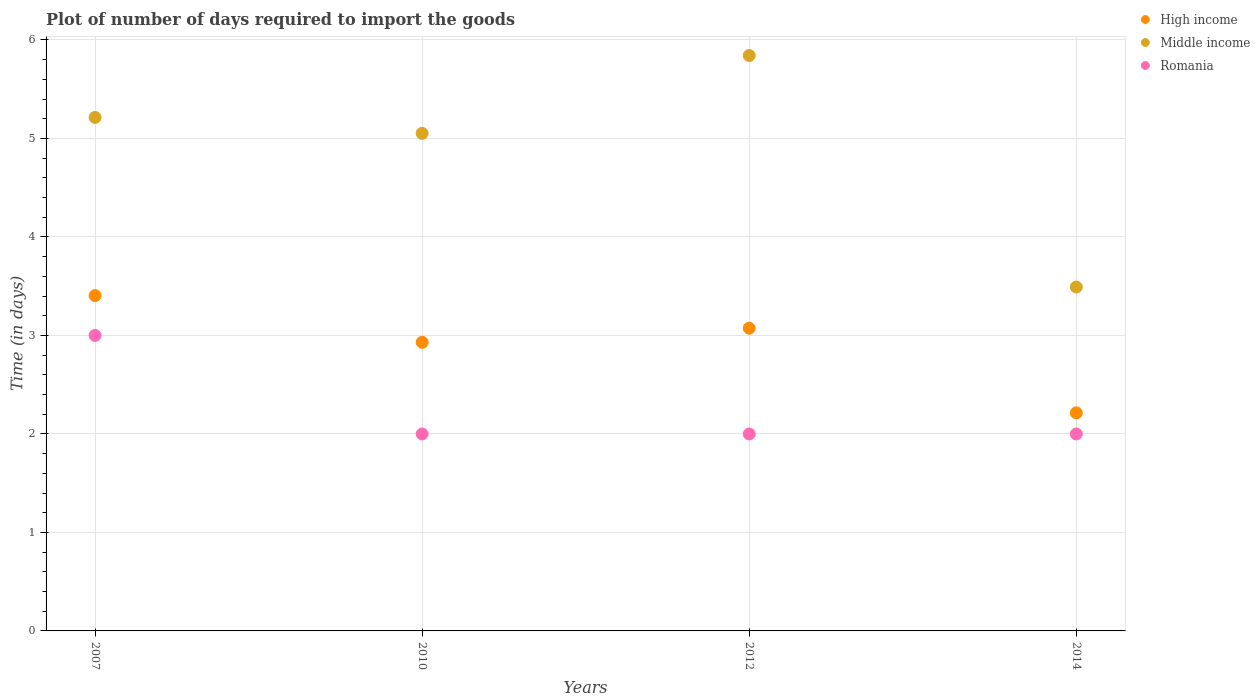How many different coloured dotlines are there?
Make the answer very short. 3. Is the number of dotlines equal to the number of legend labels?
Offer a terse response. Yes. What is the time required to import goods in Romania in 2007?
Offer a very short reply. 3. Across all years, what is the maximum time required to import goods in Middle income?
Your answer should be very brief. 5.84. Across all years, what is the minimum time required to import goods in High income?
Offer a very short reply. 2.21. In which year was the time required to import goods in Romania maximum?
Make the answer very short. 2007. In which year was the time required to import goods in High income minimum?
Provide a succinct answer. 2014. What is the total time required to import goods in Romania in the graph?
Offer a very short reply. 9. What is the difference between the time required to import goods in Romania in 2007 and that in 2012?
Give a very brief answer. 1. What is the difference between the time required to import goods in Romania in 2010 and the time required to import goods in High income in 2012?
Give a very brief answer. -1.07. What is the average time required to import goods in Middle income per year?
Make the answer very short. 4.9. In the year 2014, what is the difference between the time required to import goods in Middle income and time required to import goods in Romania?
Offer a very short reply. 1.49. What is the ratio of the time required to import goods in Middle income in 2010 to that in 2012?
Your answer should be very brief. 0.86. What is the difference between the highest and the second highest time required to import goods in Middle income?
Provide a succinct answer. 0.63. What is the difference between the highest and the lowest time required to import goods in High income?
Ensure brevity in your answer.  1.19. In how many years, is the time required to import goods in Romania greater than the average time required to import goods in Romania taken over all years?
Your answer should be very brief. 1. How many years are there in the graph?
Give a very brief answer. 4. Are the values on the major ticks of Y-axis written in scientific E-notation?
Your response must be concise. No. Where does the legend appear in the graph?
Your response must be concise. Top right. How many legend labels are there?
Provide a succinct answer. 3. How are the legend labels stacked?
Keep it short and to the point. Vertical. What is the title of the graph?
Provide a short and direct response. Plot of number of days required to import the goods. What is the label or title of the Y-axis?
Your answer should be very brief. Time (in days). What is the Time (in days) in High income in 2007?
Your answer should be very brief. 3.4. What is the Time (in days) in Middle income in 2007?
Your answer should be very brief. 5.21. What is the Time (in days) of Romania in 2007?
Provide a short and direct response. 3. What is the Time (in days) of High income in 2010?
Make the answer very short. 2.93. What is the Time (in days) of Middle income in 2010?
Provide a short and direct response. 5.05. What is the Time (in days) of High income in 2012?
Keep it short and to the point. 3.07. What is the Time (in days) of Middle income in 2012?
Your answer should be very brief. 5.84. What is the Time (in days) of High income in 2014?
Your response must be concise. 2.21. What is the Time (in days) of Middle income in 2014?
Provide a succinct answer. 3.49. Across all years, what is the maximum Time (in days) of High income?
Your response must be concise. 3.4. Across all years, what is the maximum Time (in days) of Middle income?
Provide a short and direct response. 5.84. Across all years, what is the minimum Time (in days) in High income?
Keep it short and to the point. 2.21. Across all years, what is the minimum Time (in days) of Middle income?
Keep it short and to the point. 3.49. Across all years, what is the minimum Time (in days) of Romania?
Offer a very short reply. 2. What is the total Time (in days) of High income in the graph?
Give a very brief answer. 11.62. What is the total Time (in days) of Middle income in the graph?
Keep it short and to the point. 19.6. What is the total Time (in days) in Romania in the graph?
Make the answer very short. 9. What is the difference between the Time (in days) of High income in 2007 and that in 2010?
Offer a terse response. 0.47. What is the difference between the Time (in days) of Middle income in 2007 and that in 2010?
Provide a succinct answer. 0.16. What is the difference between the Time (in days) of High income in 2007 and that in 2012?
Keep it short and to the point. 0.33. What is the difference between the Time (in days) in Middle income in 2007 and that in 2012?
Offer a terse response. -0.63. What is the difference between the Time (in days) in Romania in 2007 and that in 2012?
Make the answer very short. 1. What is the difference between the Time (in days) in High income in 2007 and that in 2014?
Your response must be concise. 1.19. What is the difference between the Time (in days) of Middle income in 2007 and that in 2014?
Your answer should be very brief. 1.72. What is the difference between the Time (in days) in Romania in 2007 and that in 2014?
Ensure brevity in your answer.  1. What is the difference between the Time (in days) in High income in 2010 and that in 2012?
Make the answer very short. -0.14. What is the difference between the Time (in days) of Middle income in 2010 and that in 2012?
Offer a very short reply. -0.79. What is the difference between the Time (in days) of High income in 2010 and that in 2014?
Make the answer very short. 0.72. What is the difference between the Time (in days) of Middle income in 2010 and that in 2014?
Offer a terse response. 1.56. What is the difference between the Time (in days) in High income in 2012 and that in 2014?
Offer a terse response. 0.86. What is the difference between the Time (in days) in Middle income in 2012 and that in 2014?
Make the answer very short. 2.35. What is the difference between the Time (in days) of High income in 2007 and the Time (in days) of Middle income in 2010?
Give a very brief answer. -1.65. What is the difference between the Time (in days) of High income in 2007 and the Time (in days) of Romania in 2010?
Give a very brief answer. 1.4. What is the difference between the Time (in days) in Middle income in 2007 and the Time (in days) in Romania in 2010?
Make the answer very short. 3.21. What is the difference between the Time (in days) of High income in 2007 and the Time (in days) of Middle income in 2012?
Offer a terse response. -2.44. What is the difference between the Time (in days) in High income in 2007 and the Time (in days) in Romania in 2012?
Keep it short and to the point. 1.4. What is the difference between the Time (in days) of Middle income in 2007 and the Time (in days) of Romania in 2012?
Provide a succinct answer. 3.21. What is the difference between the Time (in days) in High income in 2007 and the Time (in days) in Middle income in 2014?
Your answer should be very brief. -0.09. What is the difference between the Time (in days) in High income in 2007 and the Time (in days) in Romania in 2014?
Give a very brief answer. 1.4. What is the difference between the Time (in days) in Middle income in 2007 and the Time (in days) in Romania in 2014?
Offer a terse response. 3.21. What is the difference between the Time (in days) of High income in 2010 and the Time (in days) of Middle income in 2012?
Keep it short and to the point. -2.91. What is the difference between the Time (in days) in High income in 2010 and the Time (in days) in Romania in 2012?
Keep it short and to the point. 0.93. What is the difference between the Time (in days) of Middle income in 2010 and the Time (in days) of Romania in 2012?
Offer a terse response. 3.05. What is the difference between the Time (in days) of High income in 2010 and the Time (in days) of Middle income in 2014?
Your answer should be compact. -0.56. What is the difference between the Time (in days) of High income in 2010 and the Time (in days) of Romania in 2014?
Provide a short and direct response. 0.93. What is the difference between the Time (in days) in Middle income in 2010 and the Time (in days) in Romania in 2014?
Make the answer very short. 3.05. What is the difference between the Time (in days) in High income in 2012 and the Time (in days) in Middle income in 2014?
Give a very brief answer. -0.42. What is the difference between the Time (in days) in High income in 2012 and the Time (in days) in Romania in 2014?
Offer a terse response. 1.07. What is the difference between the Time (in days) in Middle income in 2012 and the Time (in days) in Romania in 2014?
Provide a succinct answer. 3.84. What is the average Time (in days) of High income per year?
Your answer should be compact. 2.91. What is the average Time (in days) of Middle income per year?
Provide a short and direct response. 4.9. What is the average Time (in days) of Romania per year?
Keep it short and to the point. 2.25. In the year 2007, what is the difference between the Time (in days) of High income and Time (in days) of Middle income?
Ensure brevity in your answer.  -1.81. In the year 2007, what is the difference between the Time (in days) of High income and Time (in days) of Romania?
Keep it short and to the point. 0.4. In the year 2007, what is the difference between the Time (in days) in Middle income and Time (in days) in Romania?
Your response must be concise. 2.21. In the year 2010, what is the difference between the Time (in days) of High income and Time (in days) of Middle income?
Your response must be concise. -2.12. In the year 2010, what is the difference between the Time (in days) in High income and Time (in days) in Romania?
Make the answer very short. 0.93. In the year 2010, what is the difference between the Time (in days) of Middle income and Time (in days) of Romania?
Ensure brevity in your answer.  3.05. In the year 2012, what is the difference between the Time (in days) of High income and Time (in days) of Middle income?
Make the answer very short. -2.77. In the year 2012, what is the difference between the Time (in days) of High income and Time (in days) of Romania?
Make the answer very short. 1.07. In the year 2012, what is the difference between the Time (in days) of Middle income and Time (in days) of Romania?
Your answer should be very brief. 3.84. In the year 2014, what is the difference between the Time (in days) in High income and Time (in days) in Middle income?
Make the answer very short. -1.28. In the year 2014, what is the difference between the Time (in days) of High income and Time (in days) of Romania?
Offer a terse response. 0.21. In the year 2014, what is the difference between the Time (in days) in Middle income and Time (in days) in Romania?
Your answer should be very brief. 1.49. What is the ratio of the Time (in days) of High income in 2007 to that in 2010?
Offer a very short reply. 1.16. What is the ratio of the Time (in days) of Middle income in 2007 to that in 2010?
Keep it short and to the point. 1.03. What is the ratio of the Time (in days) of Romania in 2007 to that in 2010?
Your answer should be very brief. 1.5. What is the ratio of the Time (in days) of High income in 2007 to that in 2012?
Your answer should be compact. 1.11. What is the ratio of the Time (in days) in Middle income in 2007 to that in 2012?
Give a very brief answer. 0.89. What is the ratio of the Time (in days) of Romania in 2007 to that in 2012?
Offer a terse response. 1.5. What is the ratio of the Time (in days) in High income in 2007 to that in 2014?
Offer a very short reply. 1.54. What is the ratio of the Time (in days) in Middle income in 2007 to that in 2014?
Give a very brief answer. 1.49. What is the ratio of the Time (in days) in High income in 2010 to that in 2012?
Make the answer very short. 0.95. What is the ratio of the Time (in days) of Middle income in 2010 to that in 2012?
Make the answer very short. 0.86. What is the ratio of the Time (in days) in High income in 2010 to that in 2014?
Offer a very short reply. 1.32. What is the ratio of the Time (in days) in Middle income in 2010 to that in 2014?
Give a very brief answer. 1.45. What is the ratio of the Time (in days) of High income in 2012 to that in 2014?
Offer a terse response. 1.39. What is the ratio of the Time (in days) in Middle income in 2012 to that in 2014?
Make the answer very short. 1.67. What is the ratio of the Time (in days) in Romania in 2012 to that in 2014?
Give a very brief answer. 1. What is the difference between the highest and the second highest Time (in days) of High income?
Ensure brevity in your answer.  0.33. What is the difference between the highest and the second highest Time (in days) of Middle income?
Give a very brief answer. 0.63. What is the difference between the highest and the second highest Time (in days) in Romania?
Your response must be concise. 1. What is the difference between the highest and the lowest Time (in days) in High income?
Ensure brevity in your answer.  1.19. What is the difference between the highest and the lowest Time (in days) in Middle income?
Make the answer very short. 2.35. 